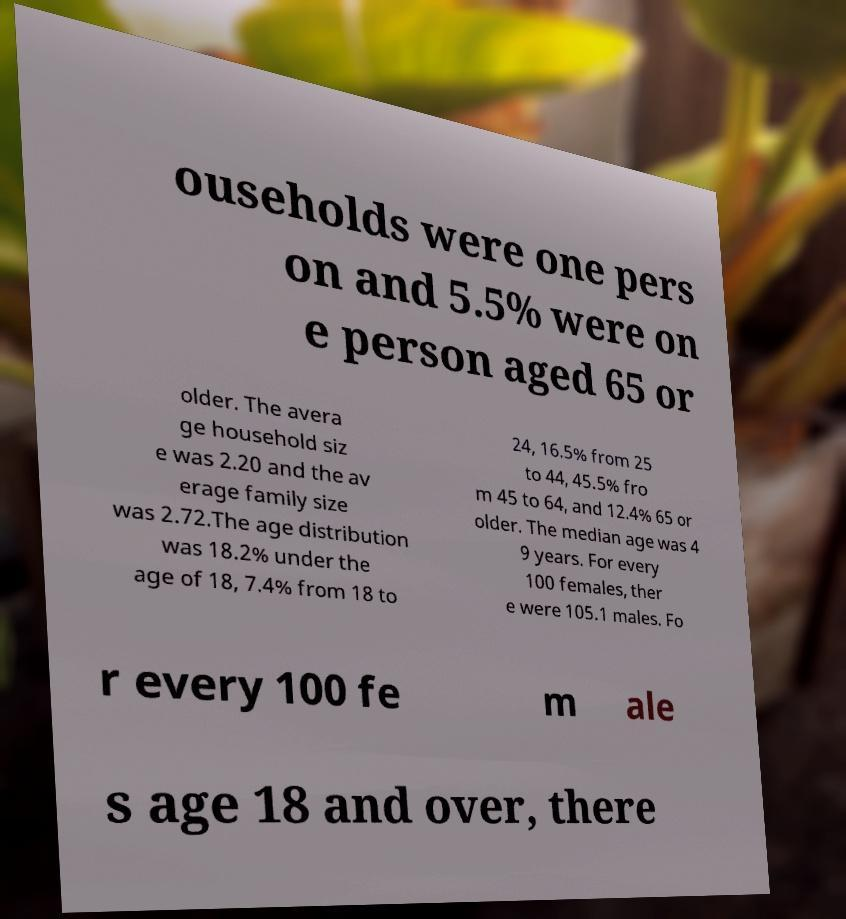What messages or text are displayed in this image? I need them in a readable, typed format. ouseholds were one pers on and 5.5% were on e person aged 65 or older. The avera ge household siz e was 2.20 and the av erage family size was 2.72.The age distribution was 18.2% under the age of 18, 7.4% from 18 to 24, 16.5% from 25 to 44, 45.5% fro m 45 to 64, and 12.4% 65 or older. The median age was 4 9 years. For every 100 females, ther e were 105.1 males. Fo r every 100 fe m ale s age 18 and over, there 